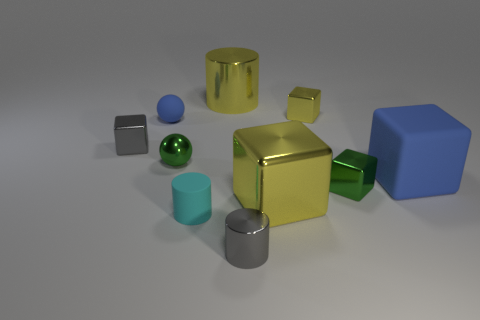Subtract 2 cubes. How many cubes are left? 3 Subtract all gray cubes. How many cubes are left? 4 Subtract all small green metal cubes. How many cubes are left? 4 Subtract all red blocks. Subtract all red spheres. How many blocks are left? 5 Subtract all spheres. How many objects are left? 8 Add 2 small objects. How many small objects are left? 9 Add 5 cyan rubber cylinders. How many cyan rubber cylinders exist? 6 Subtract 0 cyan balls. How many objects are left? 10 Subtract all large green metallic balls. Subtract all large blue cubes. How many objects are left? 9 